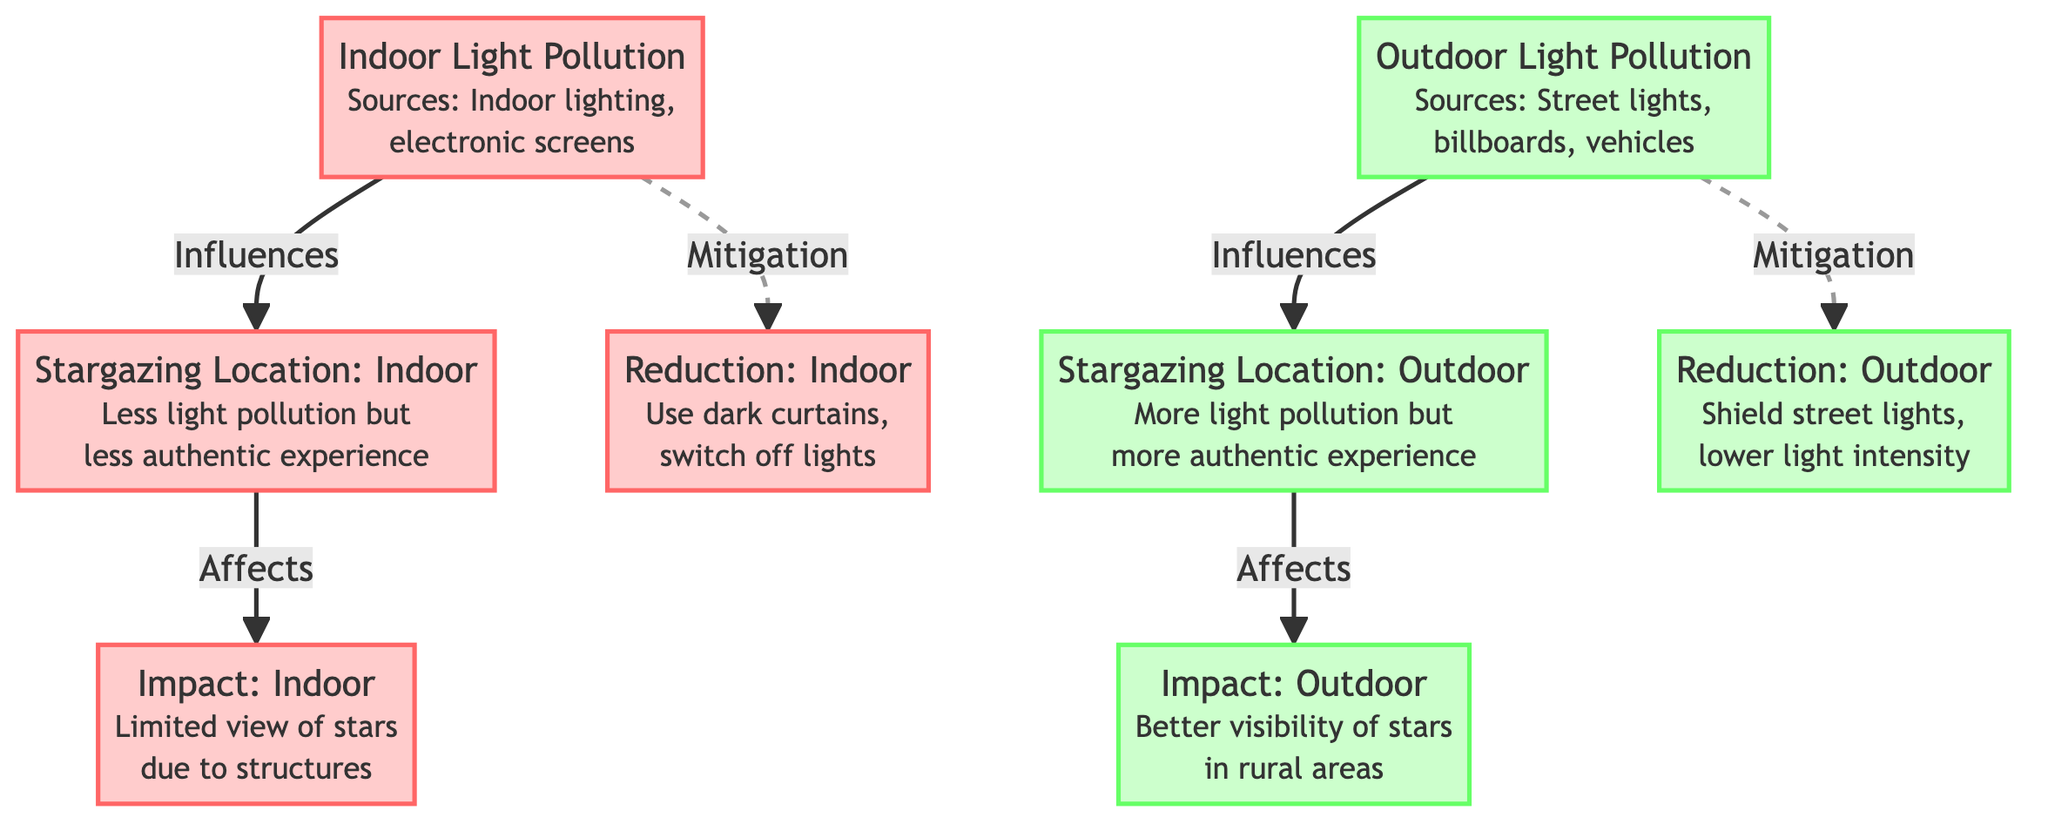What are the sources of indoor light pollution? The diagram specifies that indoor light pollution comes from sources such as indoor lighting and electronic screens. This is found in the node labeled "Indoor Light Pollution".
Answer: Indoor lighting, electronic screens What influences the stargazing location for indoor light pollution? The impact of indoor light pollution on stargazing is shown in the diagram. The node related to indoor light pollution points to the stargazing location that confirms indoor light pollution influences this location.
Answer: Indoor light pollution What is the necessary action for reducing indoor light pollution? The diagram illustrates that mitigation for indoor light pollution includes using dark curtains and switching off lights, as indicated in the node for reduction under indoor pollution.
Answer: Use dark curtains, switch off lights How does outdoor light pollution affect the visibility of stars? According to the diagram, the outdoor stargazing location is impacted by outdoor light pollution, which can lead to better visibility of stars specifically in rural areas. The relationship shows that outdoor conditions potentially enhance the stargazing experience.
Answer: Better visibility of stars Which type of location provides a more authentic stargazing experience, indoor or outdoor? The diagram states that the outdoor stargazing location is more authentic. The connection from outdoor light pollution to the stargazing location indicates this distinction clearly.
Answer: Outdoor What is one mitigation measure for outdoor light pollution? In the diagram, the mitigation node associated with outdoor light pollution suggests shielding street lights and lowering light intensity as measures to reduce its impact on stargazing.
Answer: Shield street lights, lower light intensity How many nodes relate to indoor light pollution? The diagram indicates that there are four nodes connected to indoor light pollution: Indoor Light Pollution, Indoor Stargazing Location, Indoor Impact, and Indoor Reduction. Counting these nodes provides the answer.
Answer: Four What type of stargazing experience is described as limited by structures? The diagram shows that the indoor stargazing experience is limited due to structures, which is noted under the impact of indoor light pollution.
Answer: Indoor What do both light pollution types influence? Upon examining the diagram, both indoor and outdoor light pollution influence their respective stargazing locations. This relationship is depicted through the connections in the flowchart.
Answer: Stargazing locations 